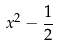Convert formula to latex. <formula><loc_0><loc_0><loc_500><loc_500>x ^ { 2 } - \frac { 1 } { 2 }</formula> 